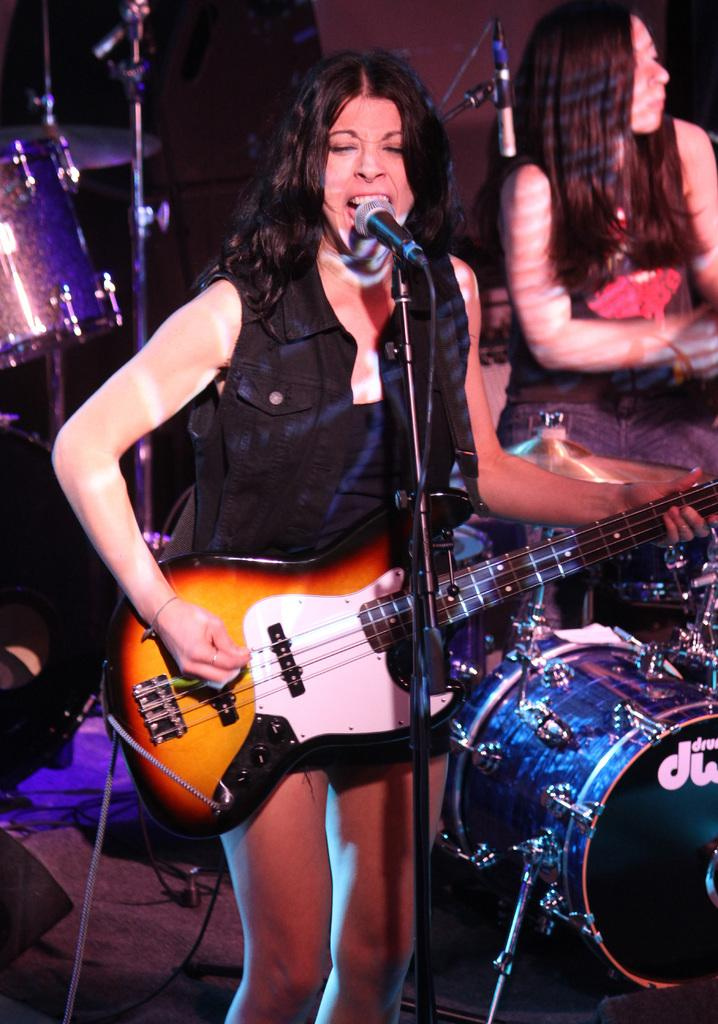What is the woman in the image doing? The woman is standing and playing guitar in the image. Is the woman singing in the image? Yes, the woman is singing with the help of a microphone. Can you describe the other person in the image? There is another woman seated in the background. What musical instrument can be seen in the image? There are drums visible in the image. What type of vein is visible on the woman's hand while she plays the guitar? There is no visible vein on the woman's hand in the image. How does the woman use a comb to play the guitar in the image? The woman is not using a comb to play the guitar in the image; she is using her fingers and a pick. 